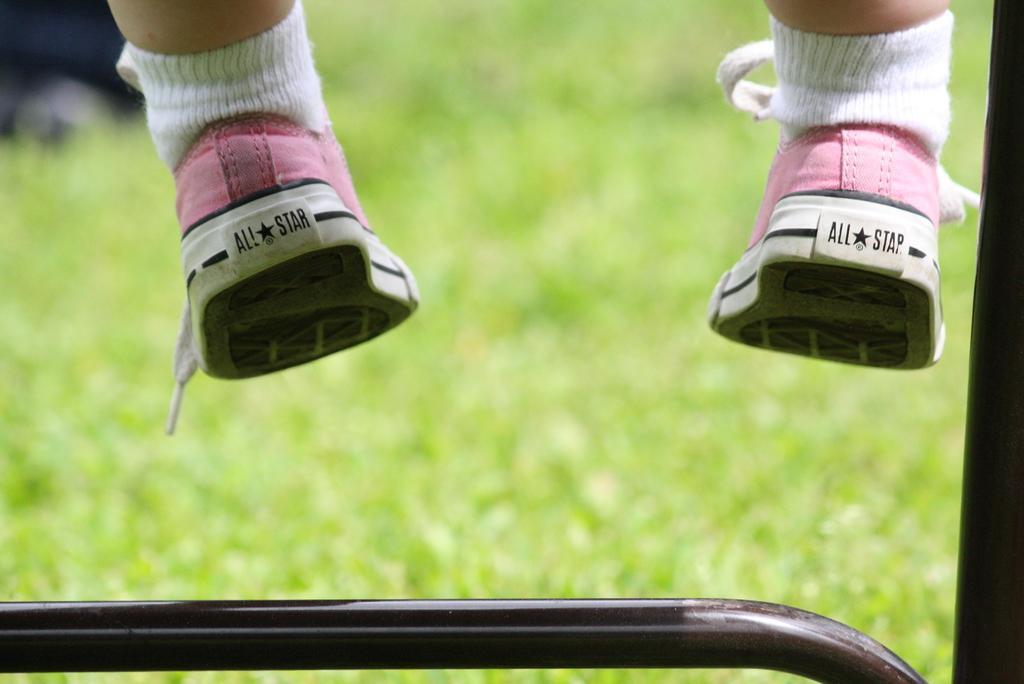Could you give a brief overview of what you see in this image? In this image, we can see person wearing socks and shoes. There is a metal rod at the bottom of the image. In the background, image is blurred. 